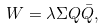<formula> <loc_0><loc_0><loc_500><loc_500>W = \lambda \Sigma Q \bar { Q } ,</formula> 